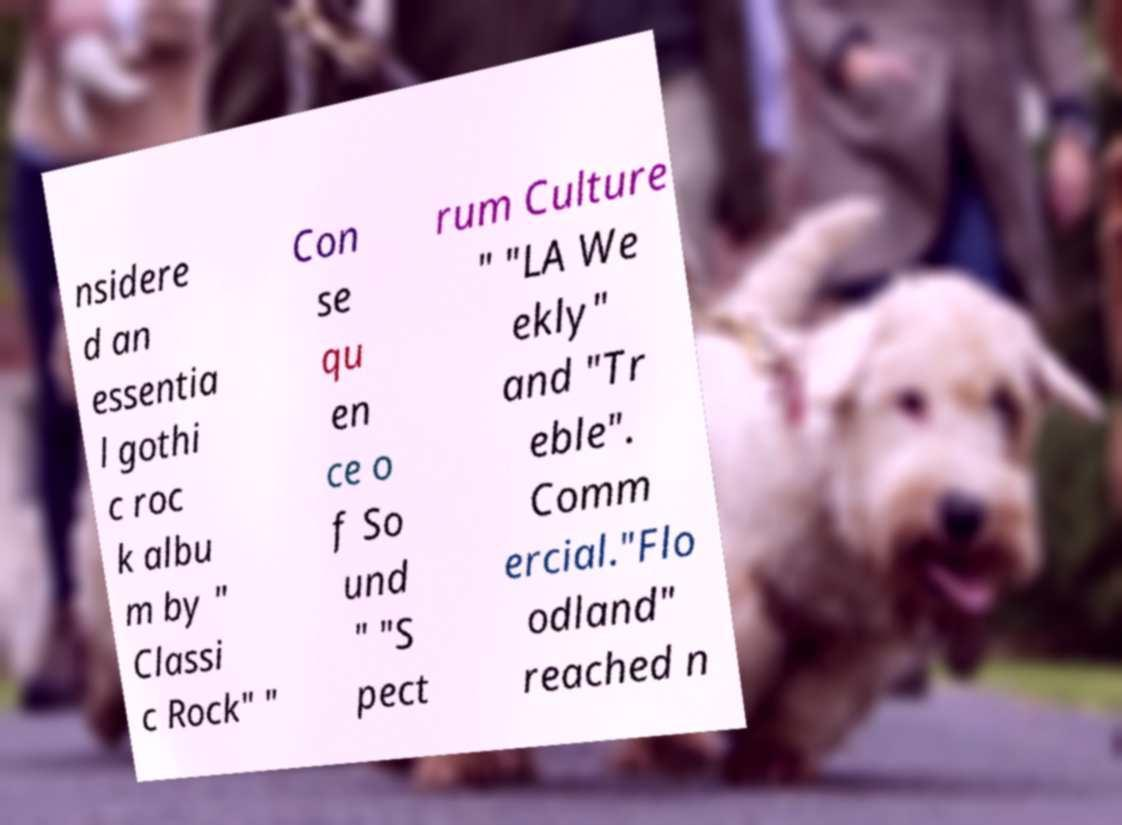Can you accurately transcribe the text from the provided image for me? nsidere d an essentia l gothi c roc k albu m by " Classi c Rock" " Con se qu en ce o f So und " "S pect rum Culture " "LA We ekly" and "Tr eble". Comm ercial."Flo odland" reached n 